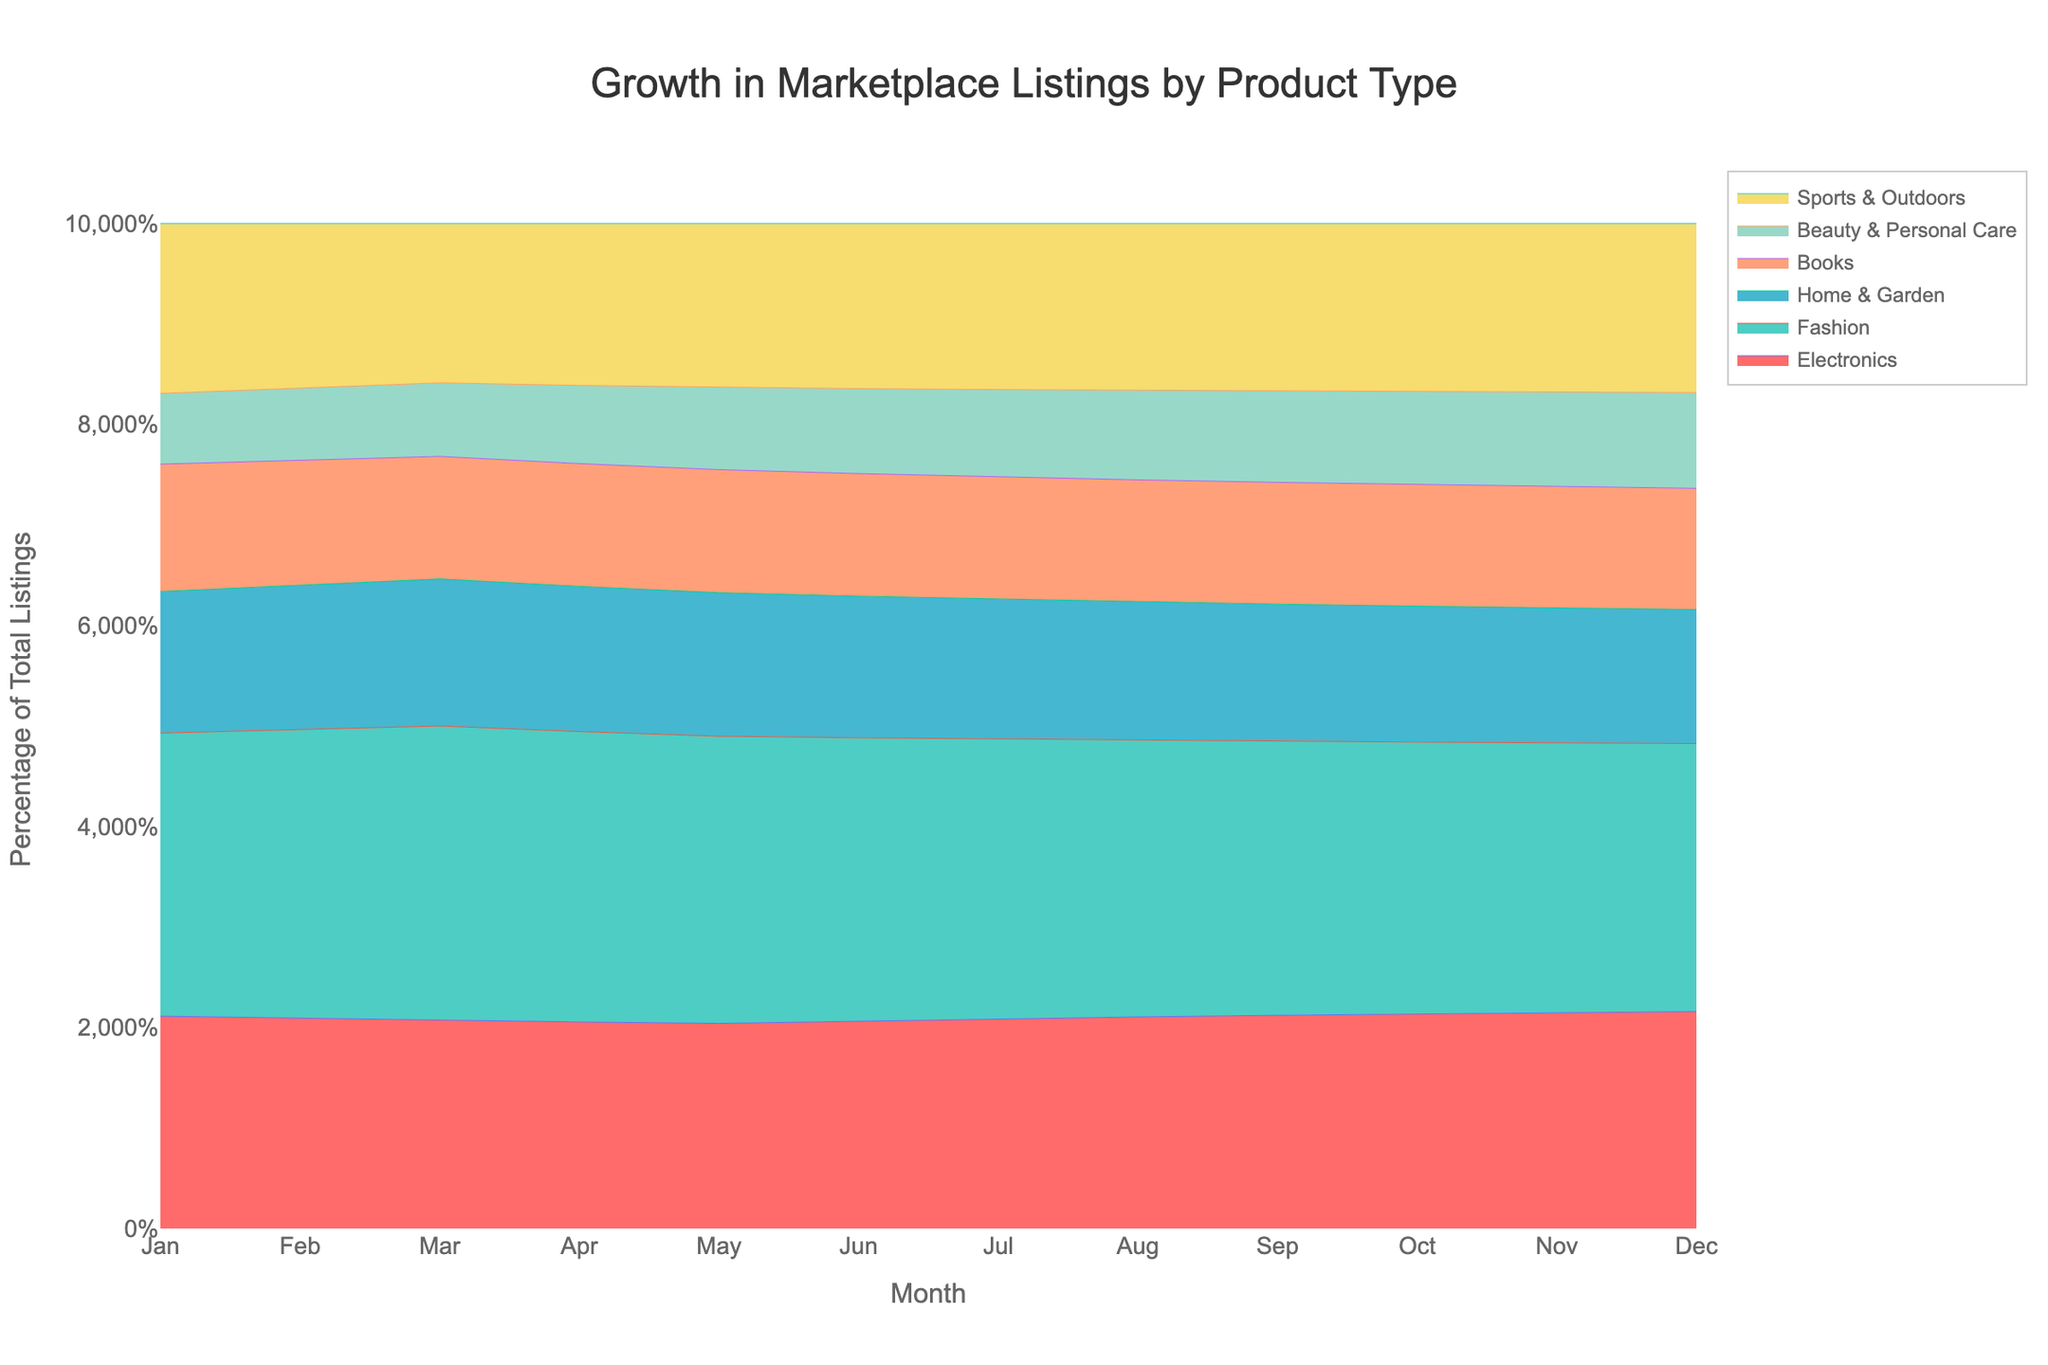what is the title of this figure? The title is located at the top center of the figure in a large font size. By reading the text, you can identify that it describes the data. The title reads "Growth in Marketplace Listings by Product Type."
Answer: Growth in Marketplace Listings by Product Type what does the y-axis represent? The y-axis, based on its label, shows the percentage of total listings rather than the absolute number of listings for each product type. This is evident from the axis title "Percentage of Total Listings" and the percentage mark pattern on the ticks (e.g., 10%, 20%).
Answer: Percentage of Total Listings How do listings for "Beauty & Personal Care" change from January to December? To answer this question, locate "Beauty & Personal Care" in the legend and identify its color. Trace its line from January (starting point) to December (end point). At the start, it represents around 50 listings and increases steadily to approximately 150 listings by December.
Answer: Increase from 50 to 150 Which product type shows the most significant growth in listings over the year? The most significant growth can be seen in the product that starts lower and ends higher compared to others. Observe each line from the beginning of the year (January) to the end (December). "Electronics" grows from 150 to 340, a growth of 190 listings.
Answer: Electronics In which month did "Home & Garden" reach 150 listings? To find this, follow the "Home & Garden" line and observe where it crosses the 150 listings mark on the y-axis. This crossover between the months of May and June indicates the 150 listings was reached in June.
Answer: June Compare the listings for "Sports & Outdoors" and "Books" in July. Which one had more listings? Locate July on the x-axis and trace both "Sports & Outdoors" and "Books" lines upwards. Compare their values: "Sports & Outdoors" hits around 190, while "Books" is at approximately 140, indicating more listings for "Sports & Outdoors".
Answer: Sports & Outdoors What percentage of the total listings in November do "Fashion" and "Home & Garden" collectively form? Identify "Fashion" (400 listings) and "Home & Garden" (200 listings) in November on the figure. Total listings for November can be approximated by summing all category listings for that month (1500). Sum of "Fashion" and "Home & Garden" is 600. Calculating this as a percentage involves 600/1500 = 40%.
Answer: 40% What trends do you observe in the listing growth for the "Books" category? Observe the "Books" line from January to December. It shows a steady increase from about 90 to 190, with no sudden spikes or drops, indicating stable growth throughout the year.
Answer: Steady growth Among all product types, which one consistently shows the least listings throughout the year? Scan all lines from January to December. "Beauty & Personal Care" consistently occupies the lowest part of the graph, with listings ranging from 50 at the start to 150 at the end.
Answer: Beauty & Personal Care 